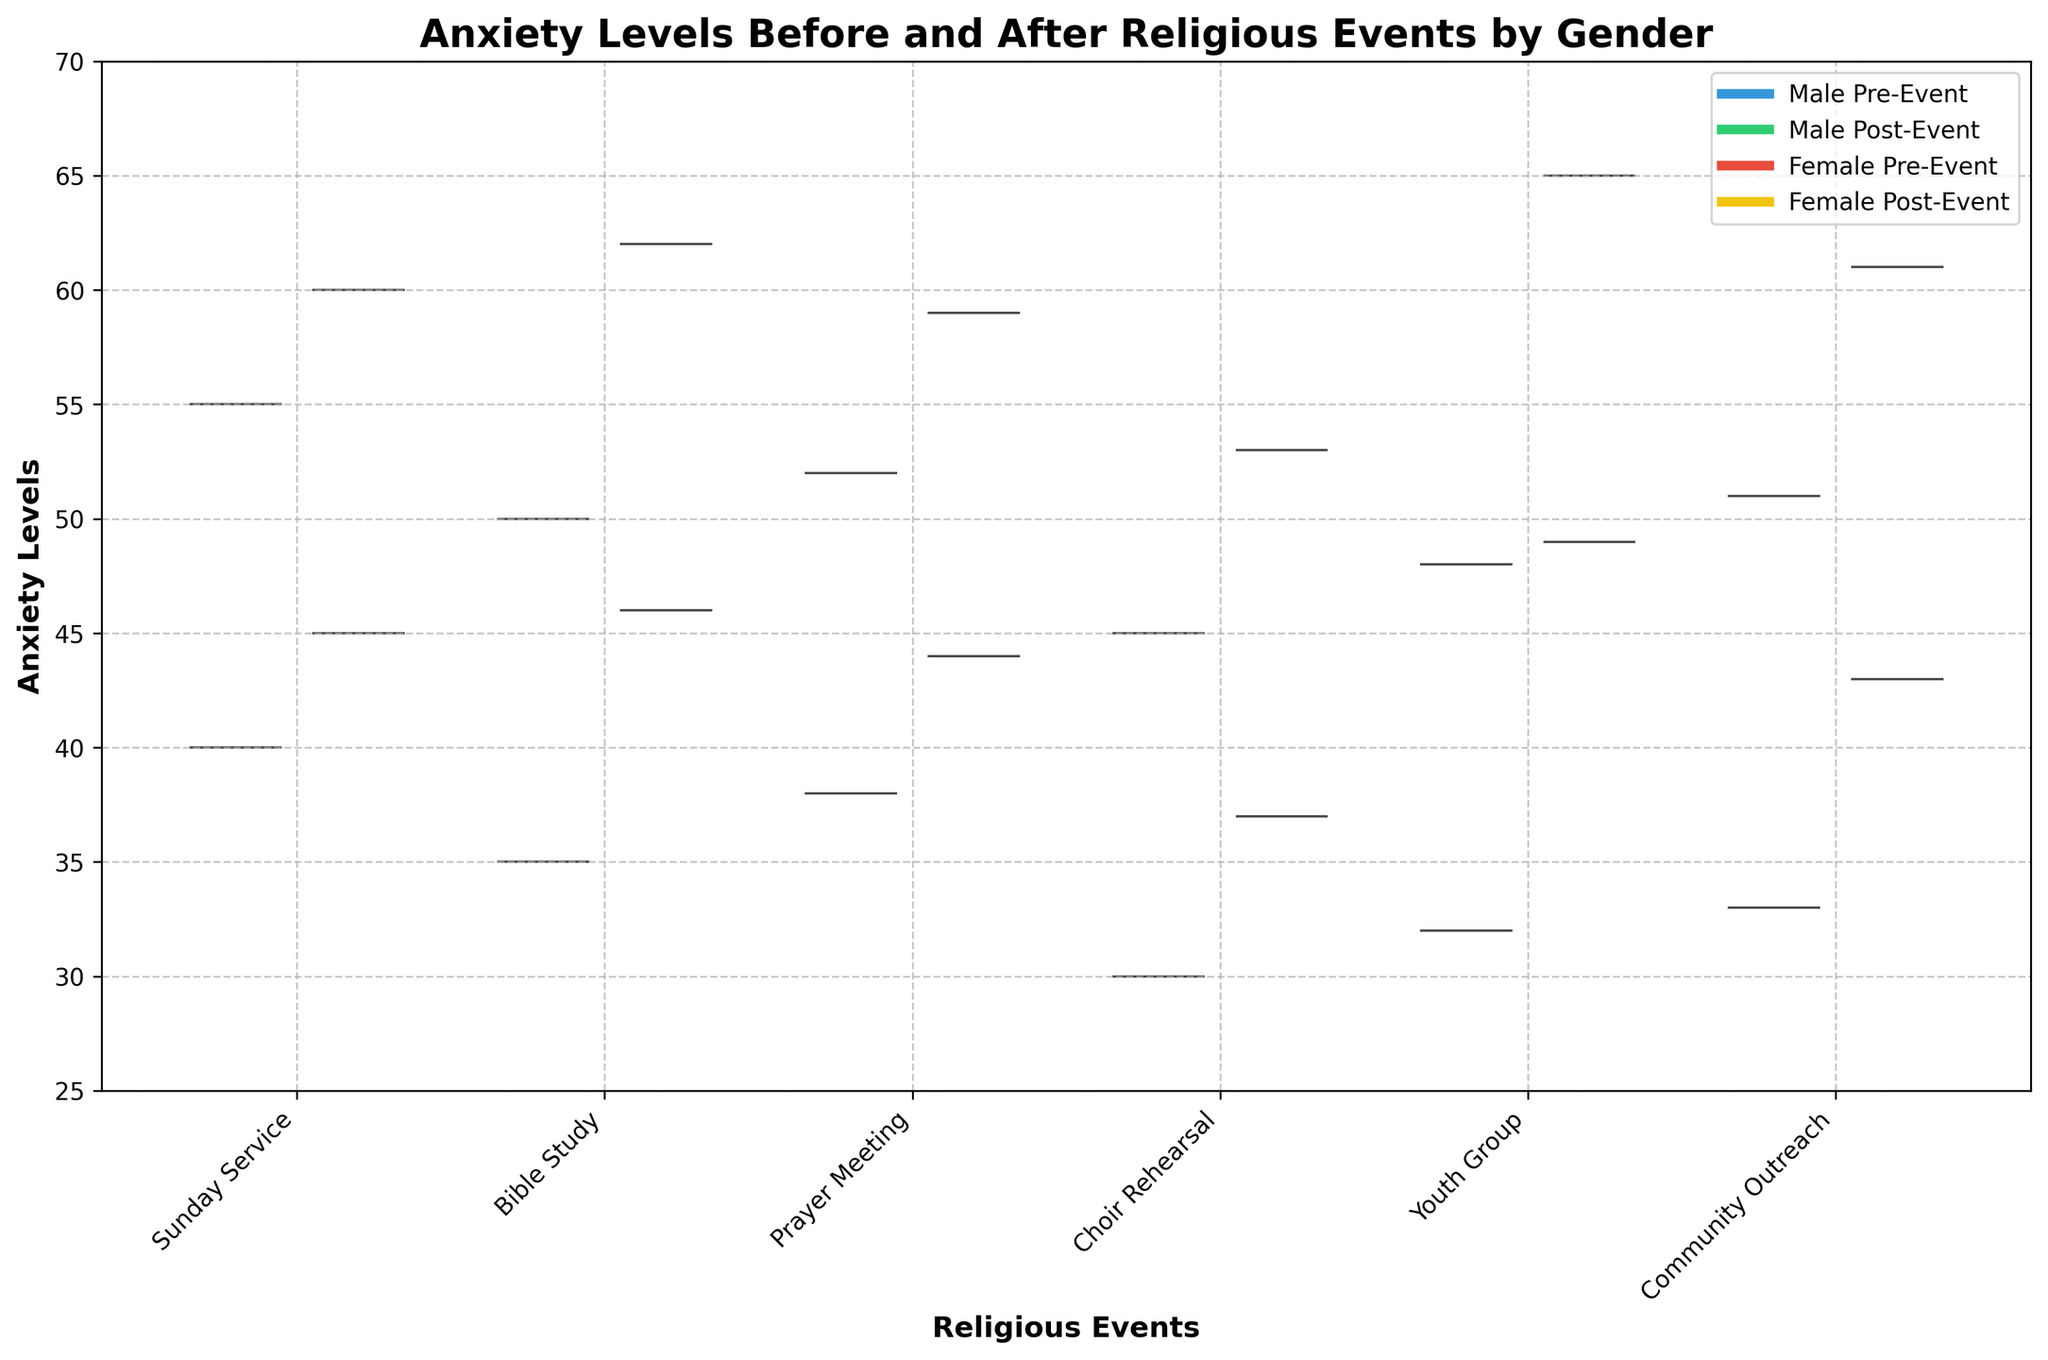What is the title of the figure? The title is located at the top of the figure in bold and larger font. It provides a brief description of the content.
Answer: Anxiety Levels Before and After Religious Events by Gender Which gender shows lower pre-event anxiety levels during the Youth Group? By comparing the positions of the violins corresponding to pre-event anxiety levels for males and females at Youth Group, we see that the males have a lower position.
Answer: Male What is the range of anxiety levels displayed on the y-axis? The y-axis values, from the bottom to top ticks, range from 25 to 70.
Answer: 25 to 70 How does female post-event anxiety level after Choir Rehearsal compare to male post-event anxiety level? We locate the violin plots for post-event anxiety of both genders after Choir Rehearsal and compare their positions. Women's violins are slightly higher in this event.
Answer: Female's is higher What's the difference between pre-event and post-event anxiety levels for females during Bible Study? Identify the pre-event and post-event violins for females during Bible Study, then calculate the difference between the two positions. Pre-event is around 62 and post-event is around 46. 62 - 46 = 16.
Answer: 16 Which event shows the highest post-event anxiety level for females? By scanning the positions of the post-event violin plots for females across all events, the highest one corresponds to the Youth Group.
Answer: Youth Group Are there any events where the post-event anxiety levels for males are higher than the pre-event levels? By visually comparing pre and post-event levels of males for each event, we notice that in all cases, post-event levels are lower than pre-event levels.
Answer: No For which event do males experience the smallest reduction in anxiety levels? Calculate the differences between pre and post-event for male participants for each event and see that the smallest occurs for Sunday Service. The difference there is 55 - 40 = 15.
Answer: Sunday Service What general trend can you observe in the anxiety levels for both genders before and after events? By comparing the pre and post-event violin positions across all events, it is evident that the post-event violins are consistently lower than pre-event violins for both genders, indicating a reduction in anxiety levels after events.
Answer: Reduction in anxiety levels During which event is the reduction in anxiety levels the most significant for males? Calculate the differences in pre and post-event levels across all events, and the largest difference is found for Choir Rehearsal, which has 45 - 30 = 15.
Answer: Choir Rehearsal 